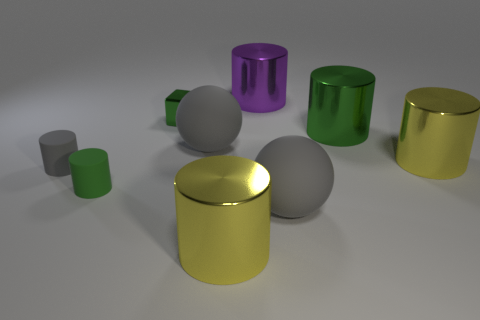Are there any other things that have the same color as the cube?
Provide a succinct answer. Yes. There is a large metallic thing that is the same color as the tiny block; what is its shape?
Your answer should be compact. Cylinder. There is a big yellow object that is on the left side of the large green cylinder; are there any yellow objects left of it?
Keep it short and to the point. No. Are any tiny gray rubber spheres visible?
Make the answer very short. No. What number of green cylinders are the same size as the block?
Keep it short and to the point. 1. What number of large objects are on the right side of the purple metal cylinder and in front of the tiny green rubber thing?
Keep it short and to the point. 1. There is a shiny cylinder that is left of the purple thing; is it the same size as the large purple shiny cylinder?
Keep it short and to the point. Yes. Are there any tiny objects that have the same color as the cube?
Offer a very short reply. Yes. What is the size of the green thing that is the same material as the small green block?
Make the answer very short. Large. Is the number of green cylinders that are behind the small green cylinder greater than the number of gray rubber balls that are to the right of the green metal cube?
Offer a very short reply. No. 